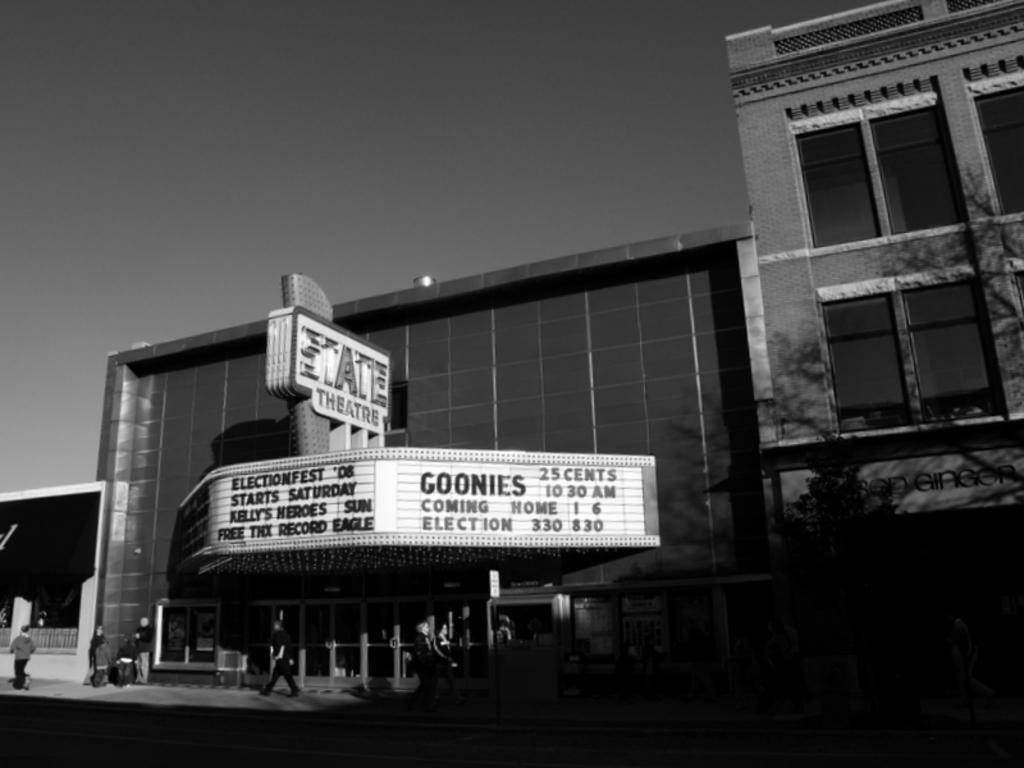Could you give a brief overview of what you see in this image? In this picture I can see many persons were standing in front of the theater. In the center i can see the theater's name and timing. On the right there is a building. At the top there is a sky. In the bottom right corner there is a tree. 